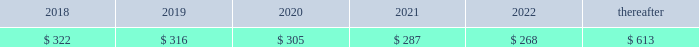92 | 2017 form 10-k finite-lived intangible assets are amortized over their estimated useful lives and tested for impairment if events or changes in circumstances indicate that the asset may be impaired .
In 2016 , gross customer relationship intangibles of $ 96 million and related accumulated amortization of $ 27 million as well as gross intellectual property intangibles of $ 111 million and related accumulated amortization of $ 48 million from the resource industries segment were impaired .
The fair value of these intangibles was determined to be insignificant based on an income approach using expected cash flows .
The fair value determination is categorized as level 3 in the fair value hierarchy due to its use of internal projections and unobservable measurement inputs .
The total impairment of $ 132 million was a result of restructuring activities and is included in other operating ( income ) expense in statement 1 .
See note 25 for information on restructuring costs .
Amortization expense related to intangible assets was $ 323 million , $ 326 million and $ 337 million for 2017 , 2016 and 2015 , respectively .
As of december 31 , 2017 , amortization expense related to intangible assets is expected to be : ( millions of dollars ) .
Goodwill there were no goodwill impairments during 2017 or 2015 .
Our annual impairment tests completed in the fourth quarter of 2016 indicated the fair value of each reporting unit was substantially above its respective carrying value , including goodwill , with the exception of our surface mining & technology reporting unit .
The surface mining & technology reporting unit , which primarily serves the mining industry , is a part of our resource industries segment .
The goodwill assigned to this reporting unit is largely from our acquisition of bucyrus international , inc .
In 2011 .
Its product portfolio includes large mining trucks , electric rope shovels , draglines , hydraulic shovels and related parts .
In addition to equipment , surface mining & technology also develops and sells technology products and services to provide customer fleet management , equipment management analytics and autonomous machine capabilities .
The annual impairment test completed in the fourth quarter of 2016 indicated that the fair value of surface mining & technology was below its carrying value requiring the second step of the goodwill impairment test process .
The fair value of surface mining & technology was determined primarily using an income approach based on a discounted ten year cash flow .
We assigned the fair value to surface mining & technology 2019s assets and liabilities using various valuation techniques that required assumptions about royalty rates , dealer attrition , technological obsolescence and discount rates .
The resulting implied fair value of goodwill was below the carrying value .
Accordingly , we recognized a goodwill impairment charge of $ 595 million , which resulted in goodwill of $ 629 million remaining for surface mining & technology as of october 1 , 2016 .
The fair value determination is categorized as level 3 in the fair value hierarchy due to its use of internal projections and unobservable measurement inputs .
There was a $ 17 million tax benefit associated with this impairment charge. .
What is the expected growth rate in amortization expense related to intangible assets from 2017 to 2018? 
Computations: ((322 - 323) / 323)
Answer: -0.0031. 